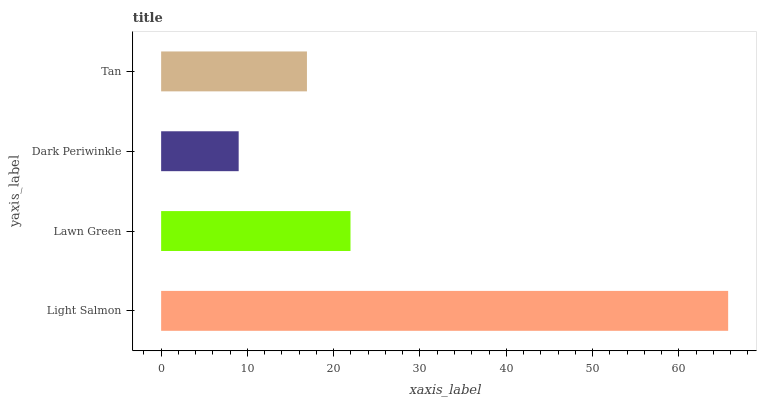Is Dark Periwinkle the minimum?
Answer yes or no. Yes. Is Light Salmon the maximum?
Answer yes or no. Yes. Is Lawn Green the minimum?
Answer yes or no. No. Is Lawn Green the maximum?
Answer yes or no. No. Is Light Salmon greater than Lawn Green?
Answer yes or no. Yes. Is Lawn Green less than Light Salmon?
Answer yes or no. Yes. Is Lawn Green greater than Light Salmon?
Answer yes or no. No. Is Light Salmon less than Lawn Green?
Answer yes or no. No. Is Lawn Green the high median?
Answer yes or no. Yes. Is Tan the low median?
Answer yes or no. Yes. Is Dark Periwinkle the high median?
Answer yes or no. No. Is Dark Periwinkle the low median?
Answer yes or no. No. 